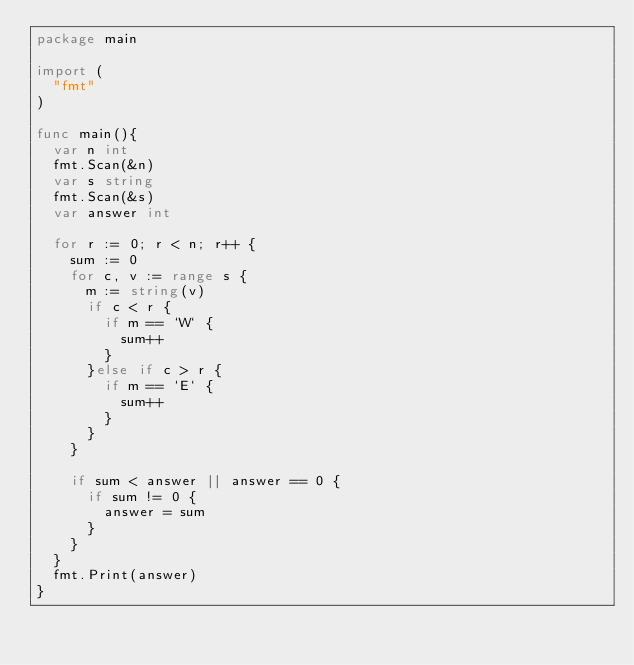Convert code to text. <code><loc_0><loc_0><loc_500><loc_500><_Go_>package main

import (
	"fmt"
)

func main(){
	var n int
	fmt.Scan(&n)
	var s string
	fmt.Scan(&s)
	var answer int

	for r := 0; r < n; r++ {
		sum := 0
		for c, v := range s {
			m := string(v)
			if c < r {
				if m == `W` {
					sum++
				}
			}else if c > r {
				if m == `E` {
					sum++
				}
			}
		}

		if sum < answer || answer == 0 {
			if sum != 0 {
				answer = sum
			}
		}
	}
	fmt.Print(answer)
}</code> 